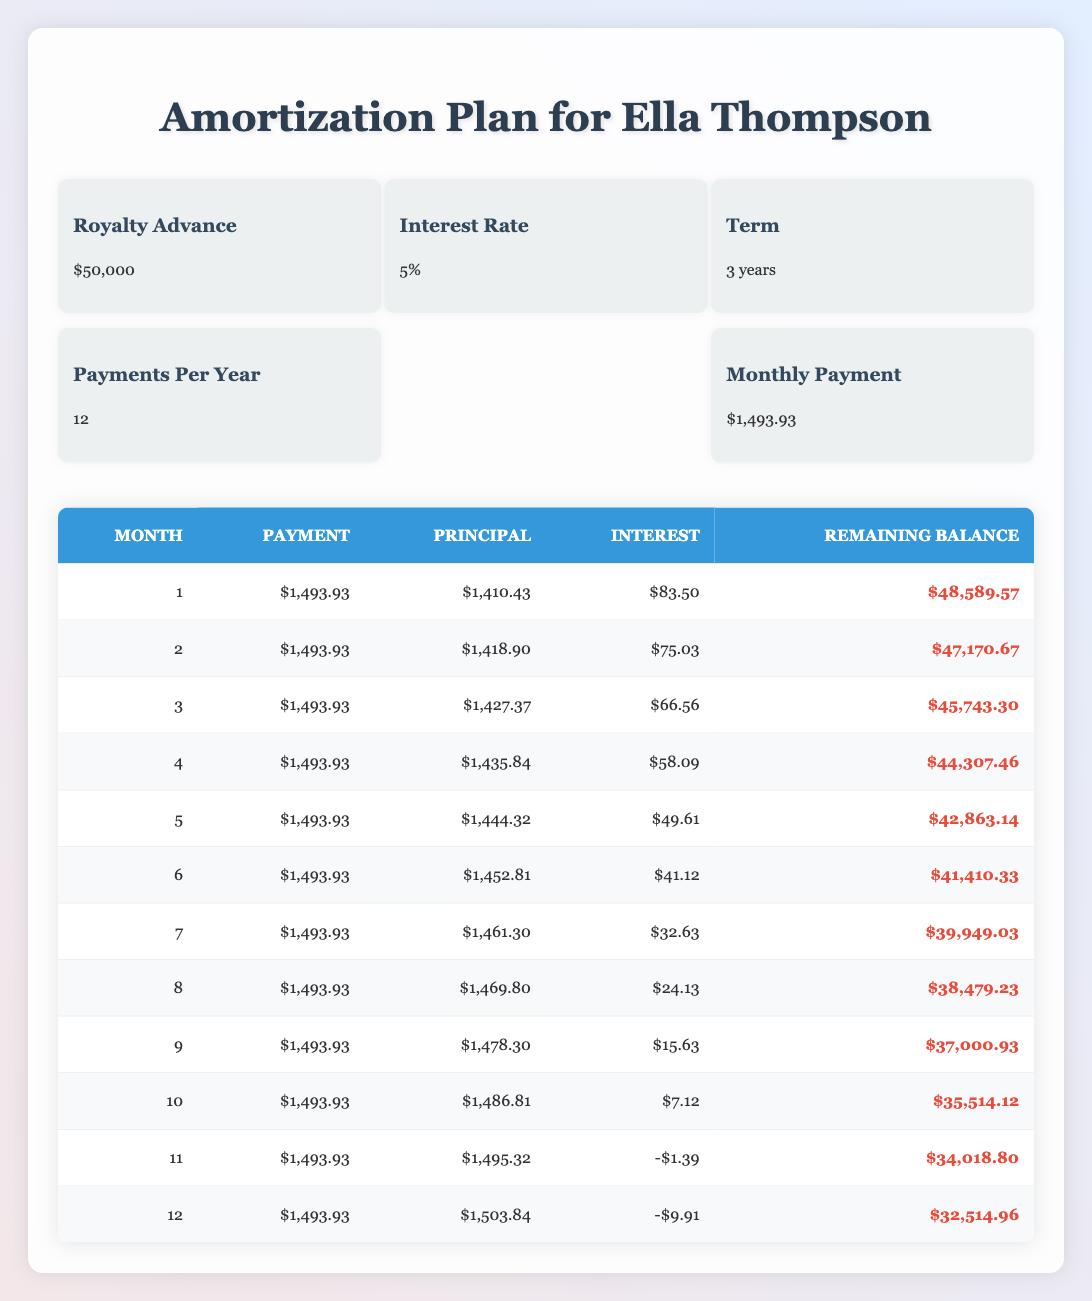What is the total amount of principal paid in the first 3 months? To calculate the total principal paid over the first three months, we sum the principal amounts of the first three payments: 1410.43 + 1418.90 + 1427.37 = 4256.70.
Answer: 4256.70 What is the remaining balance after the 12th month? The remaining balance after the 12th month is given directly in the table. It indicates a remaining balance of 32514.96.
Answer: 32514.96 Is the interest amount for the 11th month positive? The interest amount for the 11th month is -1.39, which is negative. Therefore, the statement that it is positive is false.
Answer: No What is the average monthly payment over the entire loan period? The monthly payment remains the same at 1493.93 for all 12 payments, so the average monthly payment is simply 1493.93.
Answer: 1493.93 How much total interest is paid in the first 6 months? To find the total interest paid in the first six months, we add the interest amounts from each of the first six months: 83.50 + 75.03 + 66.56 + 58.09 + 49.61 + 41.12 = 373.91.
Answer: 373.91 What is the principal amount paid in the 5th month? The principal amount paid in the 5th month is listed in the table as 1444.32.
Answer: 1444.32 How much did the remaining balance reduce from the 1st to the 2nd month? The remaining balance decreased from 48589.57 in the 1st month to 47170.67 in the 2nd month. The reduction is 48589.57 - 47170.67 = 1418.90.
Answer: 1418.90 Was the monthly payment consistent throughout the term? Yes, the monthly payment was consistently 1493.93 for all months as shown in the table. Thus, the statement is true.
Answer: Yes What is the total amount paid by the end of the 12th month? To compute the total paid by the end of the 12th month, we multiply the monthly payment by the total number of payments: 1493.93 * 12 = 17926.16.
Answer: 17926.16 